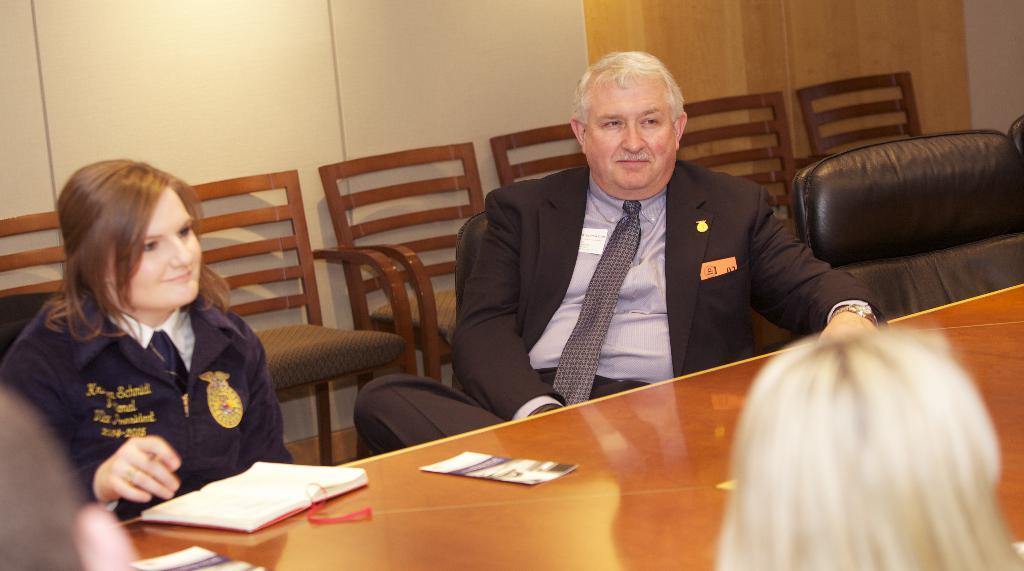How many people are sitting in the image? There are two people sitting on chairs in the image. What part of the people's bodies can be seen? The people's heads are visible in the image. What is on the table in the image? There is a book and posters on the table in the image. What can be seen in the background of the image? There is a wall behind the chairs in the image. What else is visible in the image? There are cars visible in the image. What type of guide is the person holding in the image? There is no guide visible in the image; the people are sitting and there are no objects in their hands. 